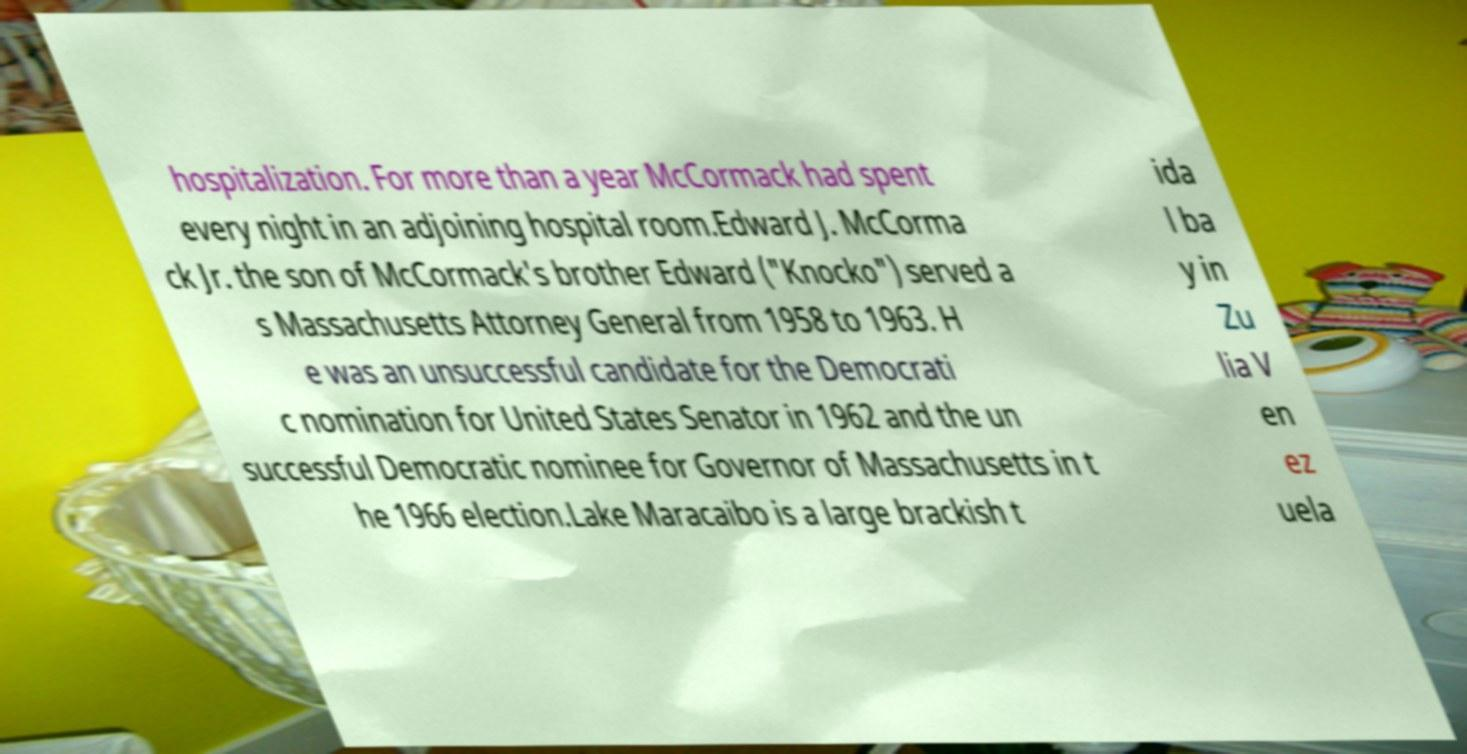For documentation purposes, I need the text within this image transcribed. Could you provide that? hospitalization. For more than a year McCormack had spent every night in an adjoining hospital room.Edward J. McCorma ck Jr. the son of McCormack's brother Edward ("Knocko") served a s Massachusetts Attorney General from 1958 to 1963. H e was an unsuccessful candidate for the Democrati c nomination for United States Senator in 1962 and the un successful Democratic nominee for Governor of Massachusetts in t he 1966 election.Lake Maracaibo is a large brackish t ida l ba y in Zu lia V en ez uela 